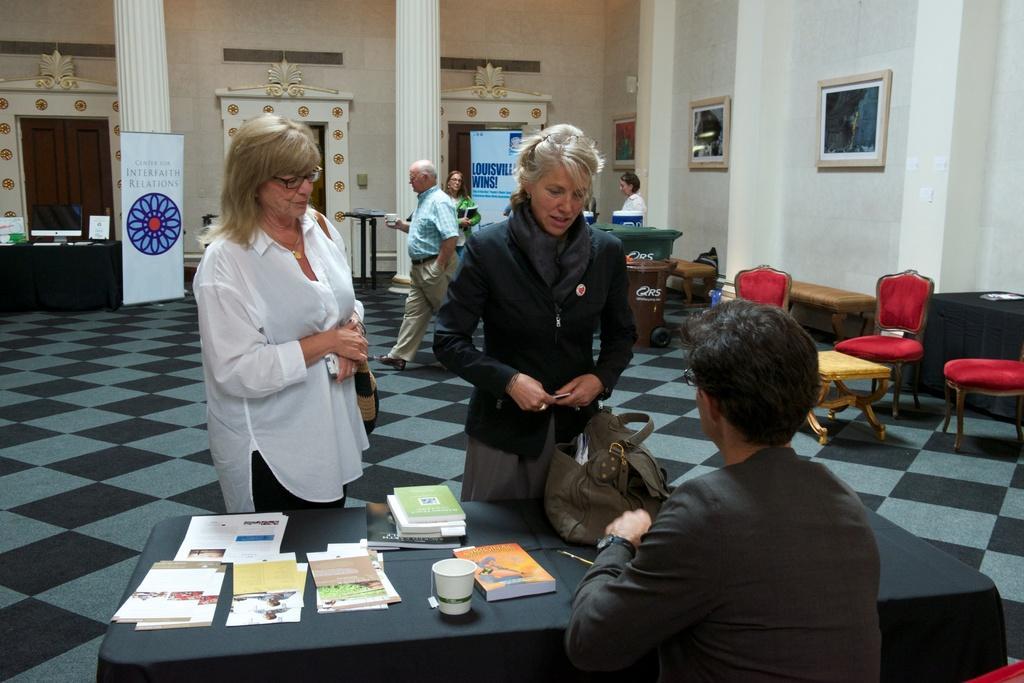Could you give a brief overview of what you see in this image? In this picture there are two people standing and there is a person sitting and we can see books, papers, cup and bag on the table. There are people and we can see chairs and we can see chairs, table, benches, banner, pillars, floor and objects. In the background of the image we can see monitor, boards and objects on the table, banner, frames on the wall, door and objects. 